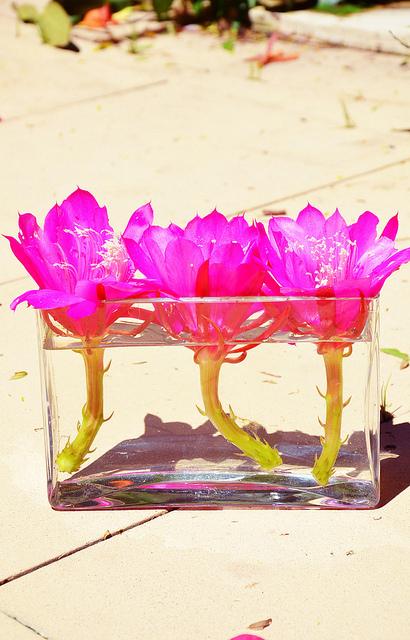Is this a form of hydroponics?
Quick response, please. Yes. What kind of flowers are these?
Answer briefly. Pink. Are the flowers real or fake?
Be succinct. Real. 